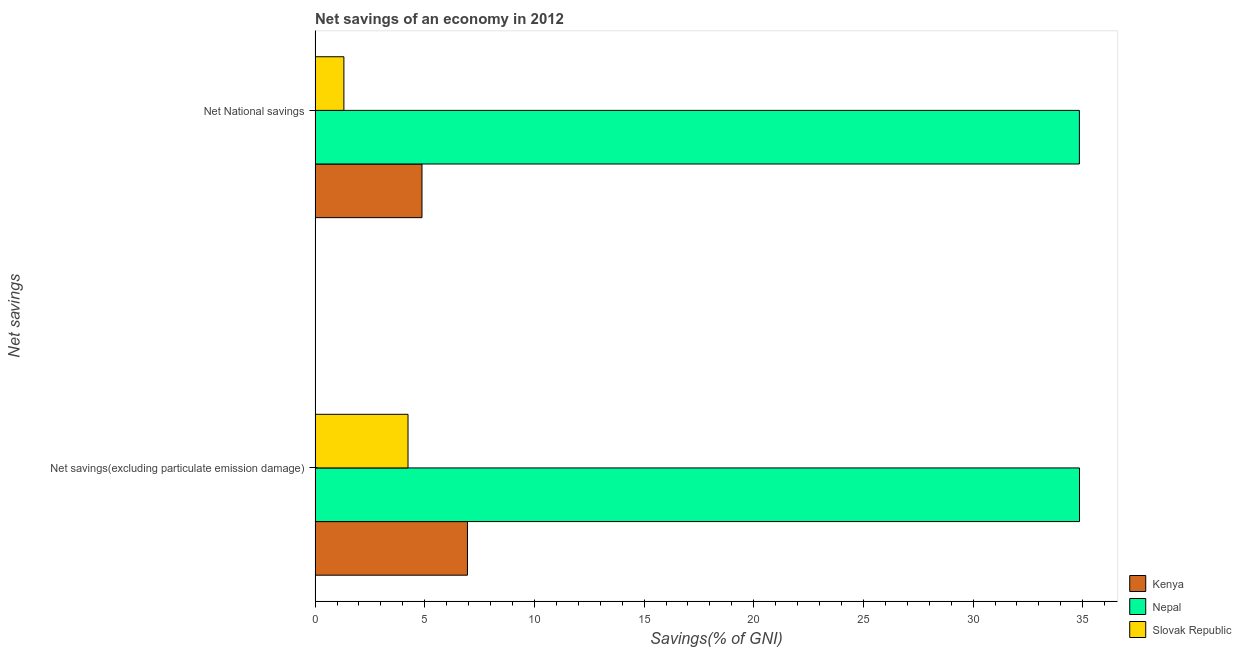How many groups of bars are there?
Your answer should be very brief. 2. Are the number of bars per tick equal to the number of legend labels?
Your answer should be compact. Yes. How many bars are there on the 2nd tick from the bottom?
Provide a short and direct response. 3. What is the label of the 1st group of bars from the top?
Provide a short and direct response. Net National savings. What is the net savings(excluding particulate emission damage) in Nepal?
Ensure brevity in your answer.  34.85. Across all countries, what is the maximum net savings(excluding particulate emission damage)?
Provide a succinct answer. 34.85. Across all countries, what is the minimum net national savings?
Offer a very short reply. 1.31. In which country was the net national savings maximum?
Give a very brief answer. Nepal. In which country was the net national savings minimum?
Your response must be concise. Slovak Republic. What is the total net national savings in the graph?
Your answer should be very brief. 41.03. What is the difference between the net national savings in Slovak Republic and that in Nepal?
Ensure brevity in your answer.  -33.54. What is the difference between the net national savings in Slovak Republic and the net savings(excluding particulate emission damage) in Nepal?
Your answer should be compact. -33.54. What is the average net savings(excluding particulate emission damage) per country?
Your answer should be compact. 15.34. What is the difference between the net national savings and net savings(excluding particulate emission damage) in Nepal?
Keep it short and to the point. -0. In how many countries, is the net savings(excluding particulate emission damage) greater than 18 %?
Keep it short and to the point. 1. What is the ratio of the net national savings in Nepal to that in Kenya?
Make the answer very short. 7.15. In how many countries, is the net national savings greater than the average net national savings taken over all countries?
Offer a very short reply. 1. What does the 1st bar from the top in Net savings(excluding particulate emission damage) represents?
Your response must be concise. Slovak Republic. What does the 2nd bar from the bottom in Net National savings represents?
Offer a terse response. Nepal. How many countries are there in the graph?
Give a very brief answer. 3. What is the difference between two consecutive major ticks on the X-axis?
Give a very brief answer. 5. Does the graph contain grids?
Your answer should be very brief. No. Where does the legend appear in the graph?
Your answer should be very brief. Bottom right. What is the title of the graph?
Your answer should be compact. Net savings of an economy in 2012. What is the label or title of the X-axis?
Your response must be concise. Savings(% of GNI). What is the label or title of the Y-axis?
Your answer should be very brief. Net savings. What is the Savings(% of GNI) of Kenya in Net savings(excluding particulate emission damage)?
Provide a succinct answer. 6.95. What is the Savings(% of GNI) in Nepal in Net savings(excluding particulate emission damage)?
Ensure brevity in your answer.  34.85. What is the Savings(% of GNI) in Slovak Republic in Net savings(excluding particulate emission damage)?
Provide a short and direct response. 4.24. What is the Savings(% of GNI) in Kenya in Net National savings?
Provide a short and direct response. 4.87. What is the Savings(% of GNI) in Nepal in Net National savings?
Your answer should be compact. 34.85. What is the Savings(% of GNI) in Slovak Republic in Net National savings?
Give a very brief answer. 1.31. Across all Net savings, what is the maximum Savings(% of GNI) of Kenya?
Ensure brevity in your answer.  6.95. Across all Net savings, what is the maximum Savings(% of GNI) of Nepal?
Provide a succinct answer. 34.85. Across all Net savings, what is the maximum Savings(% of GNI) of Slovak Republic?
Provide a succinct answer. 4.24. Across all Net savings, what is the minimum Savings(% of GNI) in Kenya?
Give a very brief answer. 4.87. Across all Net savings, what is the minimum Savings(% of GNI) in Nepal?
Your answer should be compact. 34.85. Across all Net savings, what is the minimum Savings(% of GNI) in Slovak Republic?
Your answer should be very brief. 1.31. What is the total Savings(% of GNI) in Kenya in the graph?
Offer a very short reply. 11.82. What is the total Savings(% of GNI) of Nepal in the graph?
Offer a terse response. 69.7. What is the total Savings(% of GNI) in Slovak Republic in the graph?
Provide a succinct answer. 5.55. What is the difference between the Savings(% of GNI) in Kenya in Net savings(excluding particulate emission damage) and that in Net National savings?
Your response must be concise. 2.07. What is the difference between the Savings(% of GNI) of Nepal in Net savings(excluding particulate emission damage) and that in Net National savings?
Your answer should be compact. 0. What is the difference between the Savings(% of GNI) of Slovak Republic in Net savings(excluding particulate emission damage) and that in Net National savings?
Give a very brief answer. 2.92. What is the difference between the Savings(% of GNI) in Kenya in Net savings(excluding particulate emission damage) and the Savings(% of GNI) in Nepal in Net National savings?
Make the answer very short. -27.9. What is the difference between the Savings(% of GNI) in Kenya in Net savings(excluding particulate emission damage) and the Savings(% of GNI) in Slovak Republic in Net National savings?
Offer a very short reply. 5.63. What is the difference between the Savings(% of GNI) in Nepal in Net savings(excluding particulate emission damage) and the Savings(% of GNI) in Slovak Republic in Net National savings?
Provide a succinct answer. 33.54. What is the average Savings(% of GNI) in Kenya per Net savings?
Your response must be concise. 5.91. What is the average Savings(% of GNI) in Nepal per Net savings?
Offer a terse response. 34.85. What is the average Savings(% of GNI) of Slovak Republic per Net savings?
Ensure brevity in your answer.  2.77. What is the difference between the Savings(% of GNI) of Kenya and Savings(% of GNI) of Nepal in Net savings(excluding particulate emission damage)?
Your answer should be compact. -27.91. What is the difference between the Savings(% of GNI) of Kenya and Savings(% of GNI) of Slovak Republic in Net savings(excluding particulate emission damage)?
Make the answer very short. 2.71. What is the difference between the Savings(% of GNI) in Nepal and Savings(% of GNI) in Slovak Republic in Net savings(excluding particulate emission damage)?
Offer a terse response. 30.62. What is the difference between the Savings(% of GNI) of Kenya and Savings(% of GNI) of Nepal in Net National savings?
Your answer should be compact. -29.97. What is the difference between the Savings(% of GNI) of Kenya and Savings(% of GNI) of Slovak Republic in Net National savings?
Offer a very short reply. 3.56. What is the difference between the Savings(% of GNI) of Nepal and Savings(% of GNI) of Slovak Republic in Net National savings?
Keep it short and to the point. 33.54. What is the ratio of the Savings(% of GNI) in Kenya in Net savings(excluding particulate emission damage) to that in Net National savings?
Make the answer very short. 1.43. What is the ratio of the Savings(% of GNI) of Slovak Republic in Net savings(excluding particulate emission damage) to that in Net National savings?
Offer a terse response. 3.23. What is the difference between the highest and the second highest Savings(% of GNI) of Kenya?
Your response must be concise. 2.07. What is the difference between the highest and the second highest Savings(% of GNI) of Nepal?
Your answer should be compact. 0. What is the difference between the highest and the second highest Savings(% of GNI) in Slovak Republic?
Provide a short and direct response. 2.92. What is the difference between the highest and the lowest Savings(% of GNI) in Kenya?
Your answer should be compact. 2.07. What is the difference between the highest and the lowest Savings(% of GNI) in Nepal?
Make the answer very short. 0. What is the difference between the highest and the lowest Savings(% of GNI) of Slovak Republic?
Ensure brevity in your answer.  2.92. 